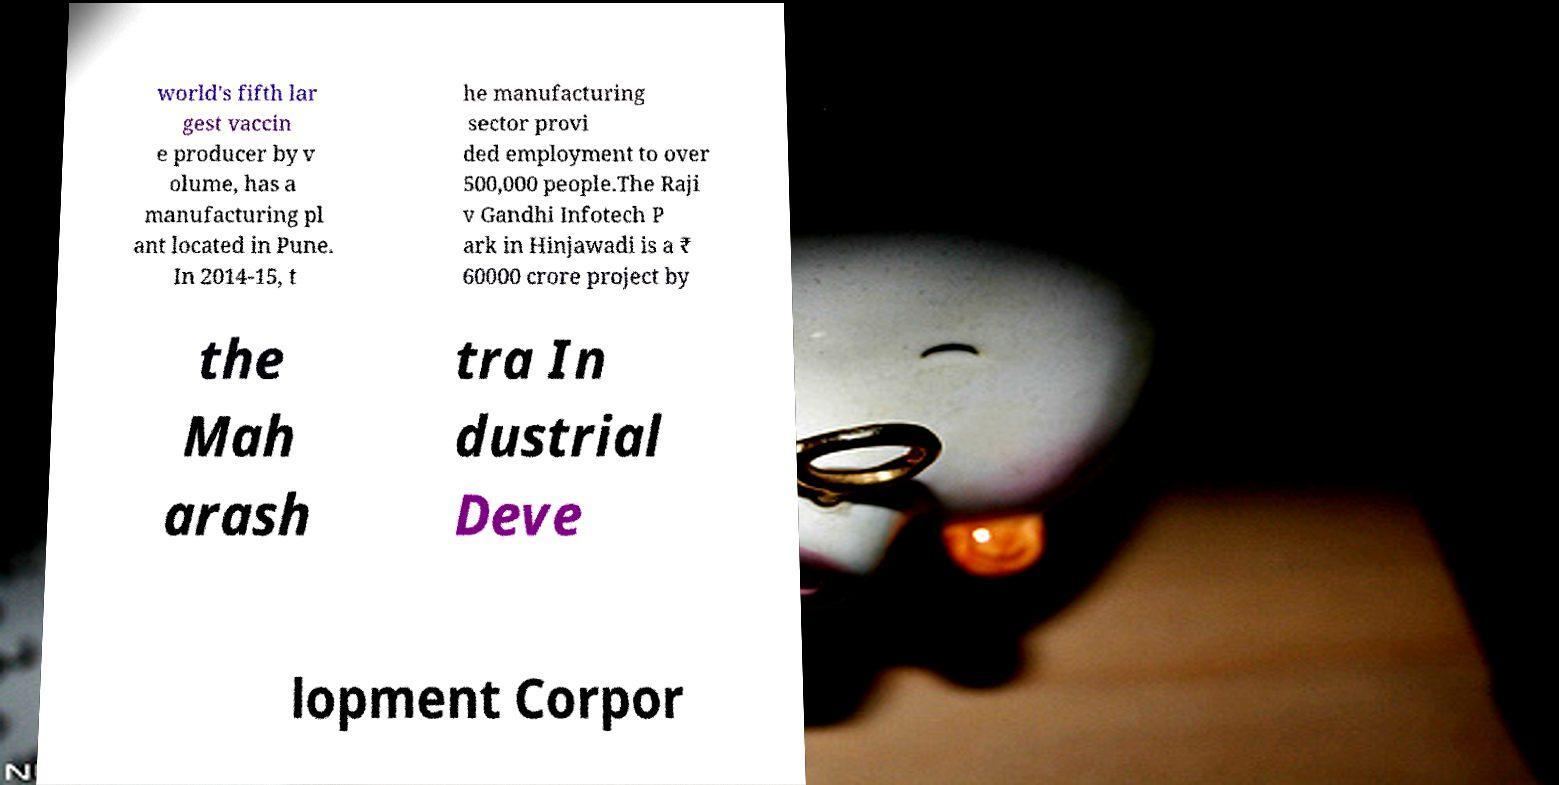What messages or text are displayed in this image? I need them in a readable, typed format. world's fifth lar gest vaccin e producer by v olume, has a manufacturing pl ant located in Pune. In 2014-15, t he manufacturing sector provi ded employment to over 500,000 people.The Raji v Gandhi Infotech P ark in Hinjawadi is a ₹ 60000 crore project by the Mah arash tra In dustrial Deve lopment Corpor 